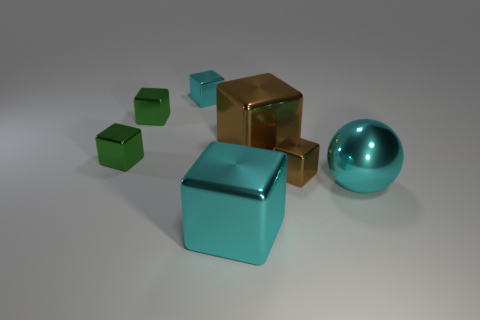Subtract 1 blocks. How many blocks are left? 5 Subtract all green cubes. How many cubes are left? 4 Subtract all big cyan shiny cubes. How many cubes are left? 5 Subtract all blue blocks. Subtract all red balls. How many blocks are left? 6 Add 1 blue objects. How many objects exist? 8 Subtract all spheres. How many objects are left? 6 Subtract all big purple matte cylinders. Subtract all cyan balls. How many objects are left? 6 Add 6 big metal spheres. How many big metal spheres are left? 7 Add 3 tiny green blocks. How many tiny green blocks exist? 5 Subtract 0 purple blocks. How many objects are left? 7 